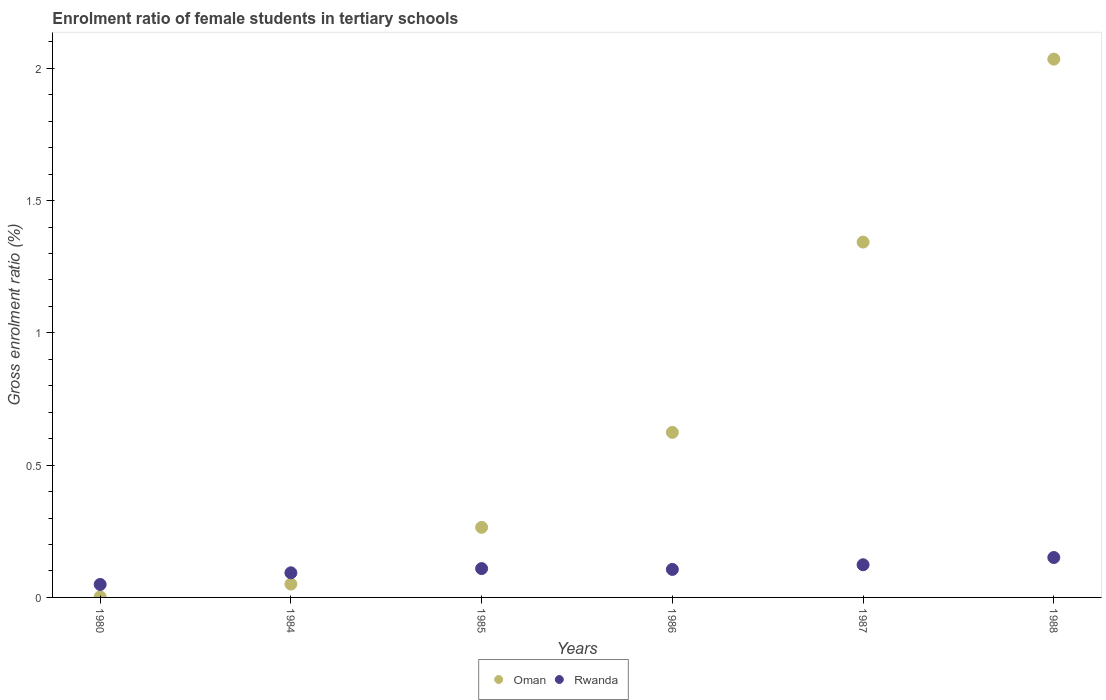How many different coloured dotlines are there?
Keep it short and to the point. 2. What is the enrolment ratio of female students in tertiary schools in Oman in 1984?
Make the answer very short. 0.05. Across all years, what is the maximum enrolment ratio of female students in tertiary schools in Rwanda?
Give a very brief answer. 0.15. Across all years, what is the minimum enrolment ratio of female students in tertiary schools in Rwanda?
Your answer should be very brief. 0.05. In which year was the enrolment ratio of female students in tertiary schools in Rwanda minimum?
Your answer should be compact. 1980. What is the total enrolment ratio of female students in tertiary schools in Rwanda in the graph?
Make the answer very short. 0.63. What is the difference between the enrolment ratio of female students in tertiary schools in Rwanda in 1985 and that in 1987?
Your response must be concise. -0.01. What is the difference between the enrolment ratio of female students in tertiary schools in Rwanda in 1988 and the enrolment ratio of female students in tertiary schools in Oman in 1986?
Your response must be concise. -0.47. What is the average enrolment ratio of female students in tertiary schools in Rwanda per year?
Provide a short and direct response. 0.11. In the year 1988, what is the difference between the enrolment ratio of female students in tertiary schools in Rwanda and enrolment ratio of female students in tertiary schools in Oman?
Ensure brevity in your answer.  -1.88. What is the ratio of the enrolment ratio of female students in tertiary schools in Oman in 1984 to that in 1986?
Make the answer very short. 0.08. Is the enrolment ratio of female students in tertiary schools in Oman in 1984 less than that in 1986?
Your response must be concise. Yes. Is the difference between the enrolment ratio of female students in tertiary schools in Rwanda in 1984 and 1988 greater than the difference between the enrolment ratio of female students in tertiary schools in Oman in 1984 and 1988?
Your answer should be very brief. Yes. What is the difference between the highest and the second highest enrolment ratio of female students in tertiary schools in Oman?
Your answer should be very brief. 0.69. What is the difference between the highest and the lowest enrolment ratio of female students in tertiary schools in Rwanda?
Provide a short and direct response. 0.1. Does the enrolment ratio of female students in tertiary schools in Rwanda monotonically increase over the years?
Provide a succinct answer. No. Is the enrolment ratio of female students in tertiary schools in Oman strictly greater than the enrolment ratio of female students in tertiary schools in Rwanda over the years?
Make the answer very short. No. How many dotlines are there?
Give a very brief answer. 2. What is the difference between two consecutive major ticks on the Y-axis?
Make the answer very short. 0.5. Are the values on the major ticks of Y-axis written in scientific E-notation?
Offer a very short reply. No. Where does the legend appear in the graph?
Keep it short and to the point. Bottom center. How many legend labels are there?
Offer a very short reply. 2. How are the legend labels stacked?
Provide a succinct answer. Horizontal. What is the title of the graph?
Make the answer very short. Enrolment ratio of female students in tertiary schools. What is the label or title of the Y-axis?
Give a very brief answer. Gross enrolment ratio (%). What is the Gross enrolment ratio (%) in Oman in 1980?
Your answer should be compact. 0. What is the Gross enrolment ratio (%) in Rwanda in 1980?
Give a very brief answer. 0.05. What is the Gross enrolment ratio (%) of Oman in 1984?
Offer a very short reply. 0.05. What is the Gross enrolment ratio (%) in Rwanda in 1984?
Keep it short and to the point. 0.09. What is the Gross enrolment ratio (%) of Oman in 1985?
Offer a very short reply. 0.26. What is the Gross enrolment ratio (%) in Rwanda in 1985?
Your answer should be compact. 0.11. What is the Gross enrolment ratio (%) in Oman in 1986?
Your answer should be compact. 0.62. What is the Gross enrolment ratio (%) in Rwanda in 1986?
Offer a very short reply. 0.11. What is the Gross enrolment ratio (%) of Oman in 1987?
Provide a succinct answer. 1.34. What is the Gross enrolment ratio (%) in Rwanda in 1987?
Provide a succinct answer. 0.12. What is the Gross enrolment ratio (%) in Oman in 1988?
Keep it short and to the point. 2.03. What is the Gross enrolment ratio (%) in Rwanda in 1988?
Make the answer very short. 0.15. Across all years, what is the maximum Gross enrolment ratio (%) in Oman?
Your answer should be compact. 2.03. Across all years, what is the maximum Gross enrolment ratio (%) in Rwanda?
Make the answer very short. 0.15. Across all years, what is the minimum Gross enrolment ratio (%) in Oman?
Keep it short and to the point. 0. Across all years, what is the minimum Gross enrolment ratio (%) in Rwanda?
Ensure brevity in your answer.  0.05. What is the total Gross enrolment ratio (%) in Oman in the graph?
Your answer should be compact. 4.32. What is the total Gross enrolment ratio (%) of Rwanda in the graph?
Offer a terse response. 0.63. What is the difference between the Gross enrolment ratio (%) in Oman in 1980 and that in 1984?
Your answer should be compact. -0.05. What is the difference between the Gross enrolment ratio (%) of Rwanda in 1980 and that in 1984?
Ensure brevity in your answer.  -0.04. What is the difference between the Gross enrolment ratio (%) in Oman in 1980 and that in 1985?
Offer a terse response. -0.26. What is the difference between the Gross enrolment ratio (%) in Rwanda in 1980 and that in 1985?
Offer a terse response. -0.06. What is the difference between the Gross enrolment ratio (%) of Oman in 1980 and that in 1986?
Provide a short and direct response. -0.62. What is the difference between the Gross enrolment ratio (%) of Rwanda in 1980 and that in 1986?
Offer a terse response. -0.06. What is the difference between the Gross enrolment ratio (%) of Oman in 1980 and that in 1987?
Give a very brief answer. -1.34. What is the difference between the Gross enrolment ratio (%) in Rwanda in 1980 and that in 1987?
Offer a very short reply. -0.07. What is the difference between the Gross enrolment ratio (%) of Oman in 1980 and that in 1988?
Give a very brief answer. -2.03. What is the difference between the Gross enrolment ratio (%) of Rwanda in 1980 and that in 1988?
Your answer should be very brief. -0.1. What is the difference between the Gross enrolment ratio (%) in Oman in 1984 and that in 1985?
Provide a succinct answer. -0.21. What is the difference between the Gross enrolment ratio (%) in Rwanda in 1984 and that in 1985?
Your answer should be compact. -0.02. What is the difference between the Gross enrolment ratio (%) in Oman in 1984 and that in 1986?
Keep it short and to the point. -0.57. What is the difference between the Gross enrolment ratio (%) in Rwanda in 1984 and that in 1986?
Offer a very short reply. -0.01. What is the difference between the Gross enrolment ratio (%) of Oman in 1984 and that in 1987?
Give a very brief answer. -1.29. What is the difference between the Gross enrolment ratio (%) in Rwanda in 1984 and that in 1987?
Provide a short and direct response. -0.03. What is the difference between the Gross enrolment ratio (%) of Oman in 1984 and that in 1988?
Your answer should be very brief. -1.98. What is the difference between the Gross enrolment ratio (%) in Rwanda in 1984 and that in 1988?
Provide a succinct answer. -0.06. What is the difference between the Gross enrolment ratio (%) of Oman in 1985 and that in 1986?
Provide a succinct answer. -0.36. What is the difference between the Gross enrolment ratio (%) of Rwanda in 1985 and that in 1986?
Provide a short and direct response. 0. What is the difference between the Gross enrolment ratio (%) of Oman in 1985 and that in 1987?
Give a very brief answer. -1.08. What is the difference between the Gross enrolment ratio (%) in Rwanda in 1985 and that in 1987?
Offer a terse response. -0.01. What is the difference between the Gross enrolment ratio (%) in Oman in 1985 and that in 1988?
Offer a very short reply. -1.77. What is the difference between the Gross enrolment ratio (%) in Rwanda in 1985 and that in 1988?
Offer a very short reply. -0.04. What is the difference between the Gross enrolment ratio (%) of Oman in 1986 and that in 1987?
Make the answer very short. -0.72. What is the difference between the Gross enrolment ratio (%) in Rwanda in 1986 and that in 1987?
Provide a short and direct response. -0.02. What is the difference between the Gross enrolment ratio (%) of Oman in 1986 and that in 1988?
Keep it short and to the point. -1.41. What is the difference between the Gross enrolment ratio (%) of Rwanda in 1986 and that in 1988?
Provide a succinct answer. -0.04. What is the difference between the Gross enrolment ratio (%) in Oman in 1987 and that in 1988?
Provide a short and direct response. -0.69. What is the difference between the Gross enrolment ratio (%) in Rwanda in 1987 and that in 1988?
Your answer should be compact. -0.03. What is the difference between the Gross enrolment ratio (%) in Oman in 1980 and the Gross enrolment ratio (%) in Rwanda in 1984?
Offer a very short reply. -0.09. What is the difference between the Gross enrolment ratio (%) in Oman in 1980 and the Gross enrolment ratio (%) in Rwanda in 1985?
Your response must be concise. -0.11. What is the difference between the Gross enrolment ratio (%) of Oman in 1980 and the Gross enrolment ratio (%) of Rwanda in 1986?
Keep it short and to the point. -0.1. What is the difference between the Gross enrolment ratio (%) of Oman in 1980 and the Gross enrolment ratio (%) of Rwanda in 1987?
Your answer should be very brief. -0.12. What is the difference between the Gross enrolment ratio (%) of Oman in 1980 and the Gross enrolment ratio (%) of Rwanda in 1988?
Give a very brief answer. -0.15. What is the difference between the Gross enrolment ratio (%) of Oman in 1984 and the Gross enrolment ratio (%) of Rwanda in 1985?
Give a very brief answer. -0.06. What is the difference between the Gross enrolment ratio (%) in Oman in 1984 and the Gross enrolment ratio (%) in Rwanda in 1986?
Offer a very short reply. -0.06. What is the difference between the Gross enrolment ratio (%) in Oman in 1984 and the Gross enrolment ratio (%) in Rwanda in 1987?
Ensure brevity in your answer.  -0.07. What is the difference between the Gross enrolment ratio (%) in Oman in 1984 and the Gross enrolment ratio (%) in Rwanda in 1988?
Offer a terse response. -0.1. What is the difference between the Gross enrolment ratio (%) of Oman in 1985 and the Gross enrolment ratio (%) of Rwanda in 1986?
Make the answer very short. 0.16. What is the difference between the Gross enrolment ratio (%) of Oman in 1985 and the Gross enrolment ratio (%) of Rwanda in 1987?
Make the answer very short. 0.14. What is the difference between the Gross enrolment ratio (%) in Oman in 1985 and the Gross enrolment ratio (%) in Rwanda in 1988?
Your answer should be compact. 0.11. What is the difference between the Gross enrolment ratio (%) in Oman in 1986 and the Gross enrolment ratio (%) in Rwanda in 1987?
Ensure brevity in your answer.  0.5. What is the difference between the Gross enrolment ratio (%) in Oman in 1986 and the Gross enrolment ratio (%) in Rwanda in 1988?
Make the answer very short. 0.47. What is the difference between the Gross enrolment ratio (%) of Oman in 1987 and the Gross enrolment ratio (%) of Rwanda in 1988?
Your response must be concise. 1.19. What is the average Gross enrolment ratio (%) in Oman per year?
Provide a short and direct response. 0.72. What is the average Gross enrolment ratio (%) of Rwanda per year?
Offer a very short reply. 0.11. In the year 1980, what is the difference between the Gross enrolment ratio (%) of Oman and Gross enrolment ratio (%) of Rwanda?
Provide a short and direct response. -0.05. In the year 1984, what is the difference between the Gross enrolment ratio (%) of Oman and Gross enrolment ratio (%) of Rwanda?
Ensure brevity in your answer.  -0.04. In the year 1985, what is the difference between the Gross enrolment ratio (%) of Oman and Gross enrolment ratio (%) of Rwanda?
Keep it short and to the point. 0.16. In the year 1986, what is the difference between the Gross enrolment ratio (%) in Oman and Gross enrolment ratio (%) in Rwanda?
Your response must be concise. 0.52. In the year 1987, what is the difference between the Gross enrolment ratio (%) of Oman and Gross enrolment ratio (%) of Rwanda?
Your answer should be very brief. 1.22. In the year 1988, what is the difference between the Gross enrolment ratio (%) of Oman and Gross enrolment ratio (%) of Rwanda?
Make the answer very short. 1.88. What is the ratio of the Gross enrolment ratio (%) in Oman in 1980 to that in 1984?
Your answer should be very brief. 0.04. What is the ratio of the Gross enrolment ratio (%) in Rwanda in 1980 to that in 1984?
Offer a very short reply. 0.53. What is the ratio of the Gross enrolment ratio (%) in Oman in 1980 to that in 1985?
Provide a short and direct response. 0.01. What is the ratio of the Gross enrolment ratio (%) of Rwanda in 1980 to that in 1985?
Offer a terse response. 0.45. What is the ratio of the Gross enrolment ratio (%) in Oman in 1980 to that in 1986?
Make the answer very short. 0. What is the ratio of the Gross enrolment ratio (%) in Rwanda in 1980 to that in 1986?
Provide a short and direct response. 0.46. What is the ratio of the Gross enrolment ratio (%) in Oman in 1980 to that in 1987?
Your answer should be compact. 0. What is the ratio of the Gross enrolment ratio (%) in Rwanda in 1980 to that in 1987?
Your answer should be compact. 0.4. What is the ratio of the Gross enrolment ratio (%) in Oman in 1980 to that in 1988?
Your answer should be very brief. 0. What is the ratio of the Gross enrolment ratio (%) of Rwanda in 1980 to that in 1988?
Your response must be concise. 0.33. What is the ratio of the Gross enrolment ratio (%) in Oman in 1984 to that in 1985?
Your response must be concise. 0.19. What is the ratio of the Gross enrolment ratio (%) of Rwanda in 1984 to that in 1985?
Your response must be concise. 0.85. What is the ratio of the Gross enrolment ratio (%) in Oman in 1984 to that in 1986?
Provide a short and direct response. 0.08. What is the ratio of the Gross enrolment ratio (%) of Rwanda in 1984 to that in 1986?
Your answer should be very brief. 0.88. What is the ratio of the Gross enrolment ratio (%) in Oman in 1984 to that in 1987?
Offer a very short reply. 0.04. What is the ratio of the Gross enrolment ratio (%) in Rwanda in 1984 to that in 1987?
Your answer should be compact. 0.75. What is the ratio of the Gross enrolment ratio (%) of Oman in 1984 to that in 1988?
Your answer should be compact. 0.02. What is the ratio of the Gross enrolment ratio (%) of Rwanda in 1984 to that in 1988?
Make the answer very short. 0.62. What is the ratio of the Gross enrolment ratio (%) in Oman in 1985 to that in 1986?
Your answer should be compact. 0.42. What is the ratio of the Gross enrolment ratio (%) of Rwanda in 1985 to that in 1986?
Provide a short and direct response. 1.03. What is the ratio of the Gross enrolment ratio (%) of Oman in 1985 to that in 1987?
Offer a very short reply. 0.2. What is the ratio of the Gross enrolment ratio (%) of Rwanda in 1985 to that in 1987?
Offer a terse response. 0.88. What is the ratio of the Gross enrolment ratio (%) in Oman in 1985 to that in 1988?
Provide a short and direct response. 0.13. What is the ratio of the Gross enrolment ratio (%) in Rwanda in 1985 to that in 1988?
Your response must be concise. 0.72. What is the ratio of the Gross enrolment ratio (%) in Oman in 1986 to that in 1987?
Ensure brevity in your answer.  0.46. What is the ratio of the Gross enrolment ratio (%) of Rwanda in 1986 to that in 1987?
Keep it short and to the point. 0.86. What is the ratio of the Gross enrolment ratio (%) of Oman in 1986 to that in 1988?
Your answer should be compact. 0.31. What is the ratio of the Gross enrolment ratio (%) of Rwanda in 1986 to that in 1988?
Offer a very short reply. 0.7. What is the ratio of the Gross enrolment ratio (%) of Oman in 1987 to that in 1988?
Keep it short and to the point. 0.66. What is the ratio of the Gross enrolment ratio (%) in Rwanda in 1987 to that in 1988?
Provide a succinct answer. 0.82. What is the difference between the highest and the second highest Gross enrolment ratio (%) in Oman?
Provide a succinct answer. 0.69. What is the difference between the highest and the second highest Gross enrolment ratio (%) in Rwanda?
Give a very brief answer. 0.03. What is the difference between the highest and the lowest Gross enrolment ratio (%) of Oman?
Offer a very short reply. 2.03. What is the difference between the highest and the lowest Gross enrolment ratio (%) of Rwanda?
Your response must be concise. 0.1. 